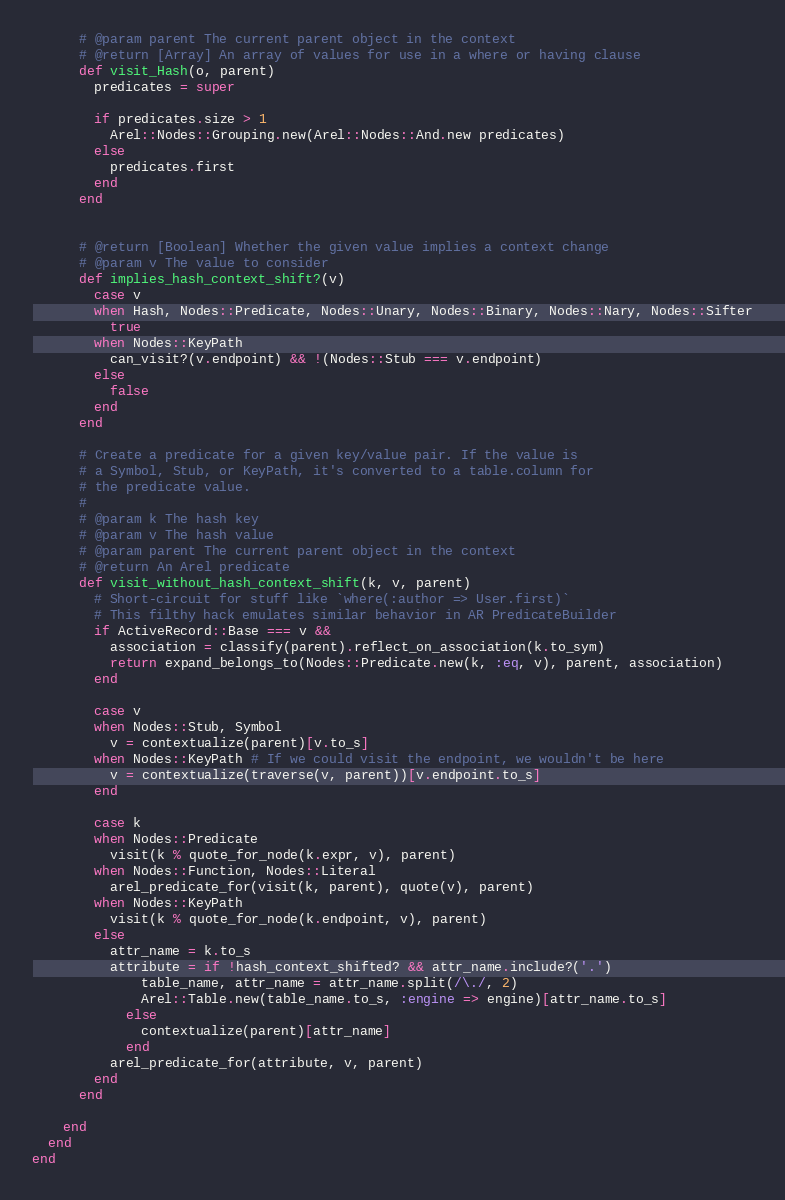<code> <loc_0><loc_0><loc_500><loc_500><_Ruby_>      # @param parent The current parent object in the context
      # @return [Array] An array of values for use in a where or having clause
      def visit_Hash(o, parent)
        predicates = super

        if predicates.size > 1
          Arel::Nodes::Grouping.new(Arel::Nodes::And.new predicates)
        else
          predicates.first
        end
      end


      # @return [Boolean] Whether the given value implies a context change
      # @param v The value to consider
      def implies_hash_context_shift?(v)
        case v
        when Hash, Nodes::Predicate, Nodes::Unary, Nodes::Binary, Nodes::Nary, Nodes::Sifter
          true
        when Nodes::KeyPath
          can_visit?(v.endpoint) && !(Nodes::Stub === v.endpoint)
        else
          false
        end
      end

      # Create a predicate for a given key/value pair. If the value is
      # a Symbol, Stub, or KeyPath, it's converted to a table.column for
      # the predicate value.
      #
      # @param k The hash key
      # @param v The hash value
      # @param parent The current parent object in the context
      # @return An Arel predicate
      def visit_without_hash_context_shift(k, v, parent)
        # Short-circuit for stuff like `where(:author => User.first)`
        # This filthy hack emulates similar behavior in AR PredicateBuilder
        if ActiveRecord::Base === v &&
          association = classify(parent).reflect_on_association(k.to_sym)
          return expand_belongs_to(Nodes::Predicate.new(k, :eq, v), parent, association)
        end

        case v
        when Nodes::Stub, Symbol
          v = contextualize(parent)[v.to_s]
        when Nodes::KeyPath # If we could visit the endpoint, we wouldn't be here
          v = contextualize(traverse(v, parent))[v.endpoint.to_s]
        end

        case k
        when Nodes::Predicate
          visit(k % quote_for_node(k.expr, v), parent)
        when Nodes::Function, Nodes::Literal
          arel_predicate_for(visit(k, parent), quote(v), parent)
        when Nodes::KeyPath
          visit(k % quote_for_node(k.endpoint, v), parent)
        else
          attr_name = k.to_s
          attribute = if !hash_context_shifted? && attr_name.include?('.')
              table_name, attr_name = attr_name.split(/\./, 2)
              Arel::Table.new(table_name.to_s, :engine => engine)[attr_name.to_s]
            else
              contextualize(parent)[attr_name]
            end
          arel_predicate_for(attribute, v, parent)
        end
      end

    end
  end
end
</code> 